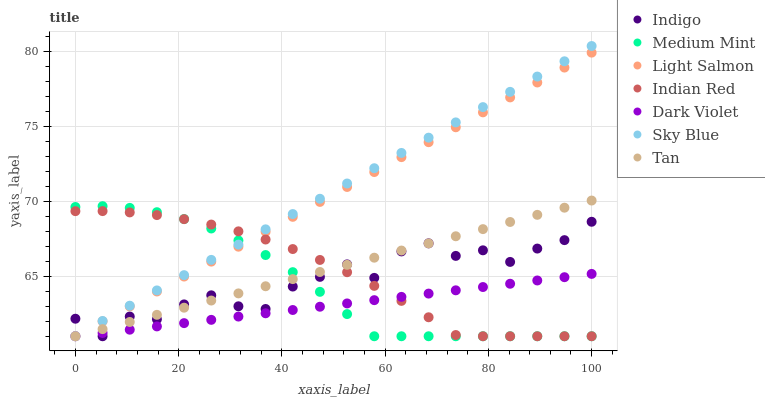Does Dark Violet have the minimum area under the curve?
Answer yes or no. Yes. Does Sky Blue have the maximum area under the curve?
Answer yes or no. Yes. Does Light Salmon have the minimum area under the curve?
Answer yes or no. No. Does Light Salmon have the maximum area under the curve?
Answer yes or no. No. Is Tan the smoothest?
Answer yes or no. Yes. Is Indigo the roughest?
Answer yes or no. Yes. Is Light Salmon the smoothest?
Answer yes or no. No. Is Light Salmon the roughest?
Answer yes or no. No. Does Medium Mint have the lowest value?
Answer yes or no. Yes. Does Sky Blue have the highest value?
Answer yes or no. Yes. Does Light Salmon have the highest value?
Answer yes or no. No. Does Light Salmon intersect Indigo?
Answer yes or no. Yes. Is Light Salmon less than Indigo?
Answer yes or no. No. Is Light Salmon greater than Indigo?
Answer yes or no. No. 